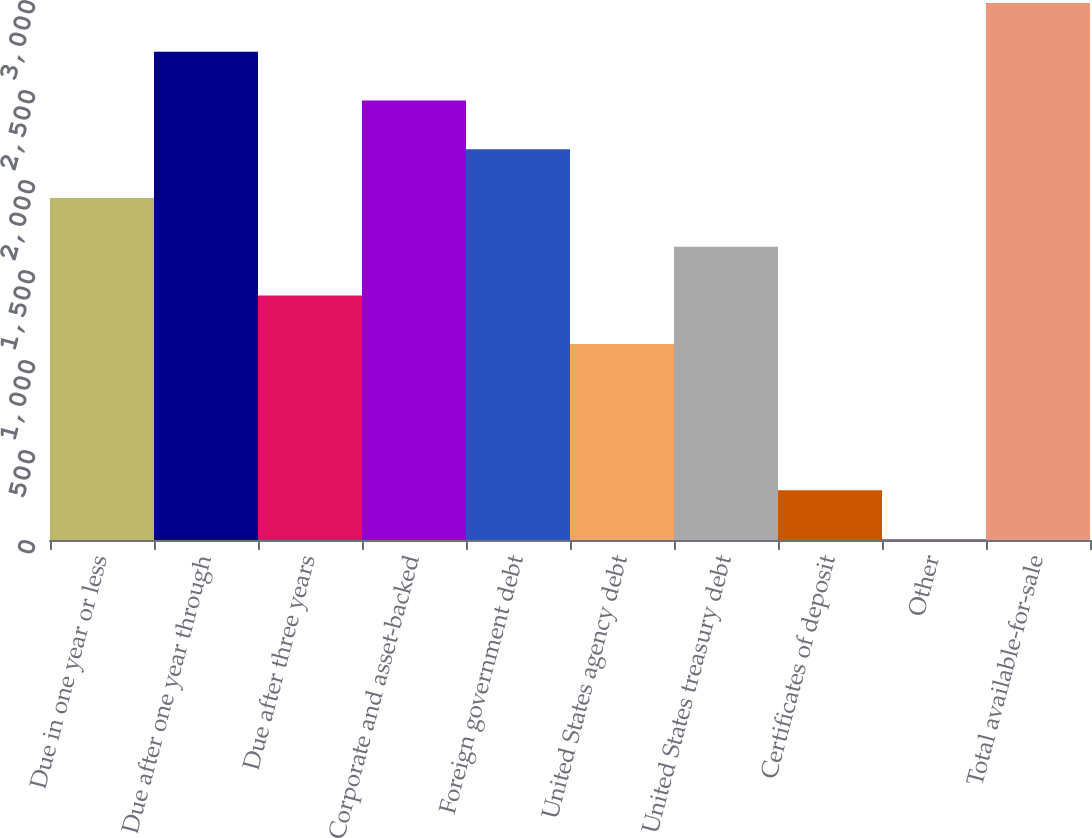<chart> <loc_0><loc_0><loc_500><loc_500><bar_chart><fcel>Due in one year or less<fcel>Due after one year through<fcel>Due after three years<fcel>Corporate and asset-backed<fcel>Foreign government debt<fcel>United States agency debt<fcel>United States treasury debt<fcel>Certificates of deposit<fcel>Other<fcel>Total available-for-sale<nl><fcel>1900.6<fcel>2713<fcel>1359<fcel>2442.2<fcel>2171.4<fcel>1088.2<fcel>1629.8<fcel>275.8<fcel>5<fcel>2983.8<nl></chart> 